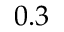<formula> <loc_0><loc_0><loc_500><loc_500>0 . 3</formula> 